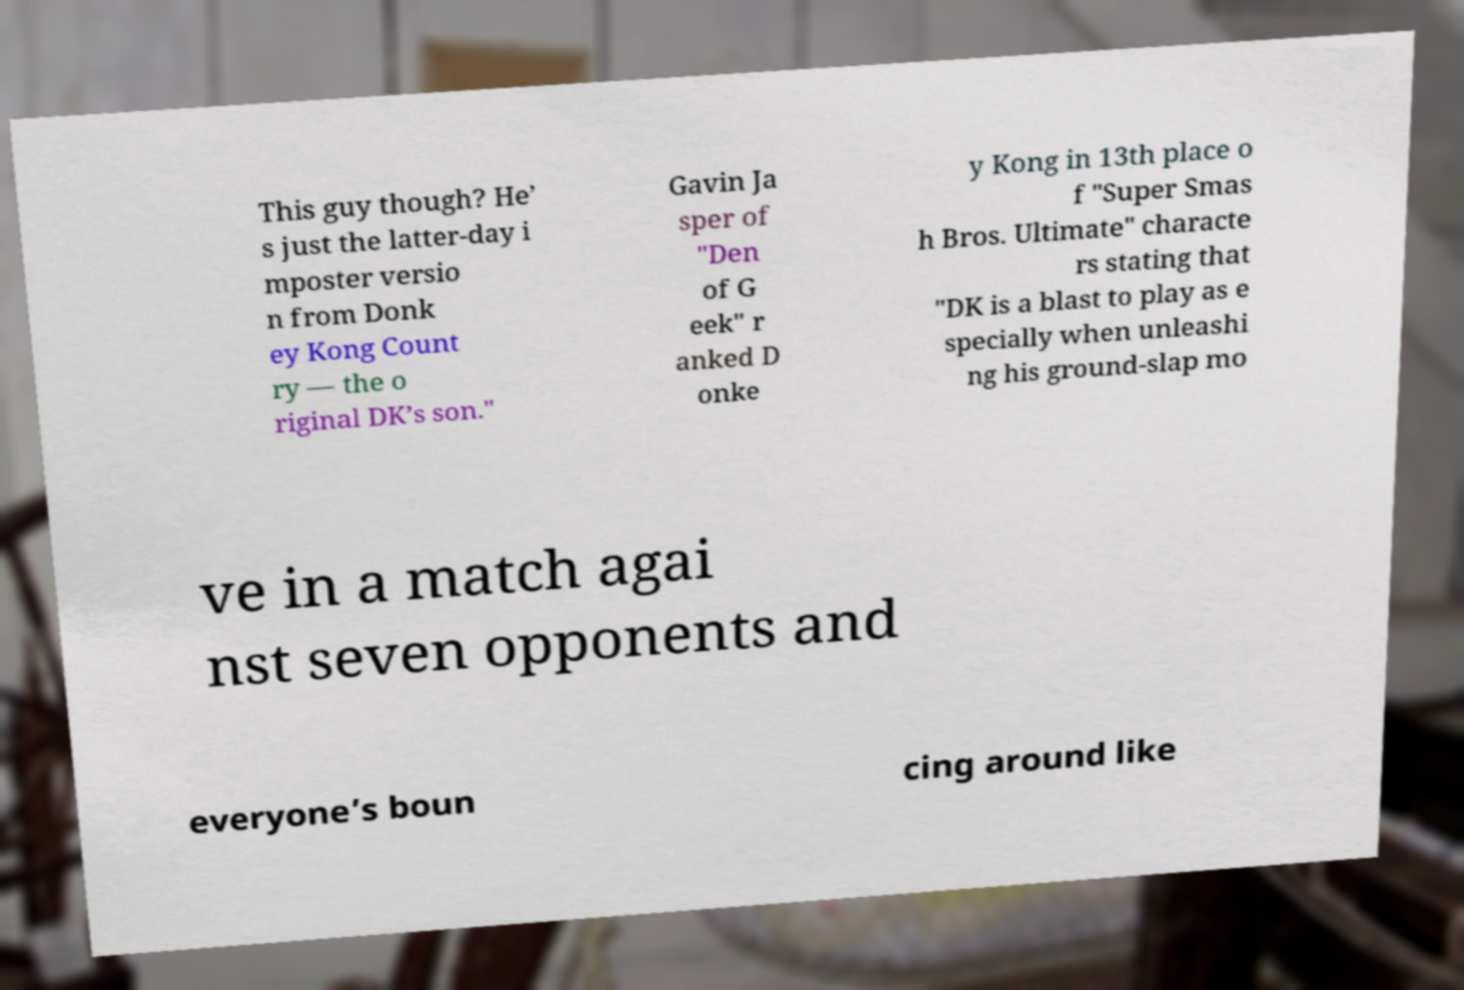Can you read and provide the text displayed in the image?This photo seems to have some interesting text. Can you extract and type it out for me? This guy though? He’ s just the latter-day i mposter versio n from Donk ey Kong Count ry — the o riginal DK’s son." Gavin Ja sper of "Den of G eek" r anked D onke y Kong in 13th place o f "Super Smas h Bros. Ultimate" characte rs stating that "DK is a blast to play as e specially when unleashi ng his ground-slap mo ve in a match agai nst seven opponents and everyone’s boun cing around like 